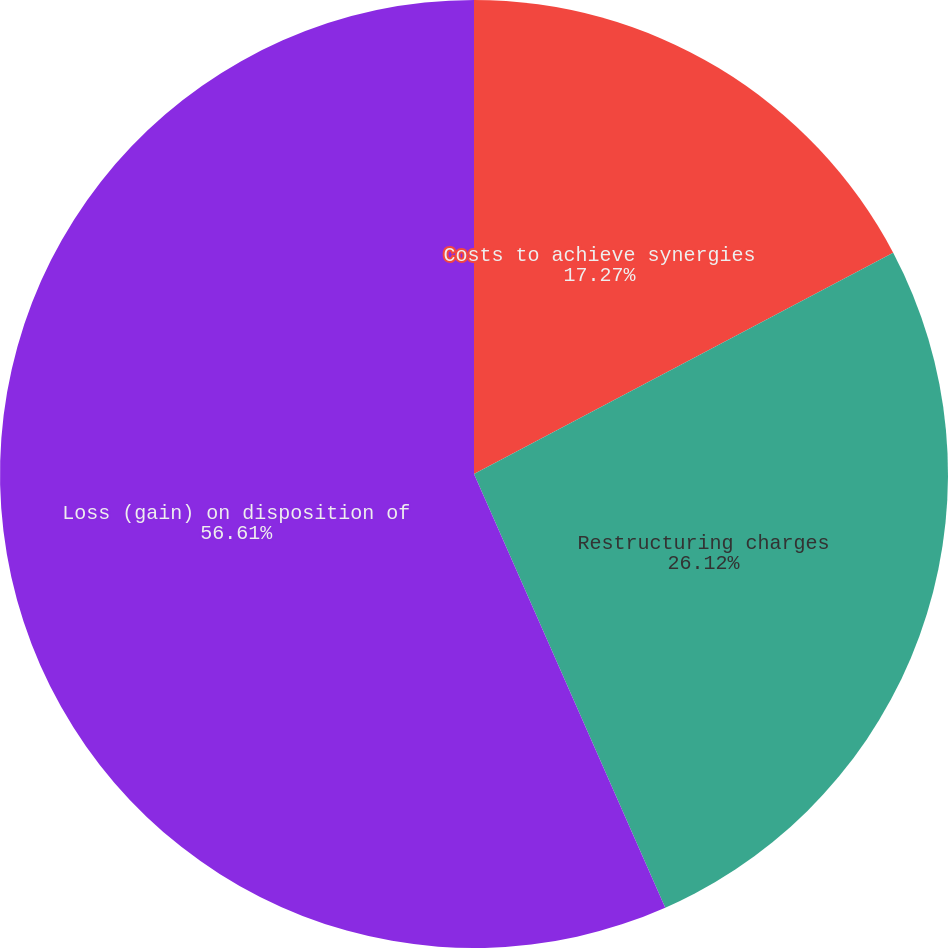<chart> <loc_0><loc_0><loc_500><loc_500><pie_chart><fcel>Costs to achieve synergies<fcel>Restructuring charges<fcel>Loss (gain) on disposition of<nl><fcel>17.27%<fcel>26.12%<fcel>56.61%<nl></chart> 